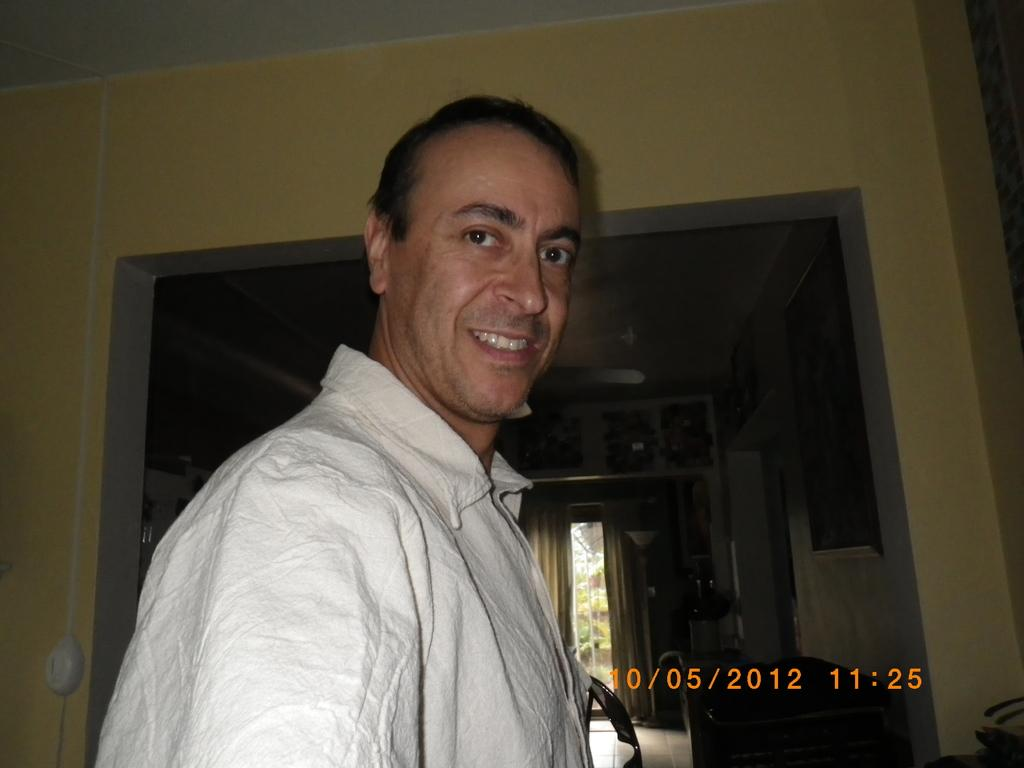What is the main subject of the image? The main subject of the image is a man. What is the man doing in the image? The man is looking at his side in the image. What is the man wearing in the image? The man is wearing a shirt in the image. What type of quill is the man holding in the image? There is no quill present in the image; the man is not holding any object. 